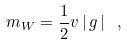Convert formula to latex. <formula><loc_0><loc_0><loc_500><loc_500>m _ { W } = { \frac { 1 } { 2 } } v \left | \, g \, \right | \ ,</formula> 